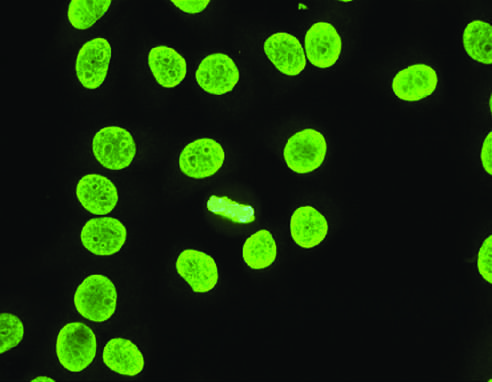s homogeneous or diffuse staining of nuclei typical of antibodies reactive with dsdna, nucleosomes, and histones?
Answer the question using a single word or phrase. Yes 